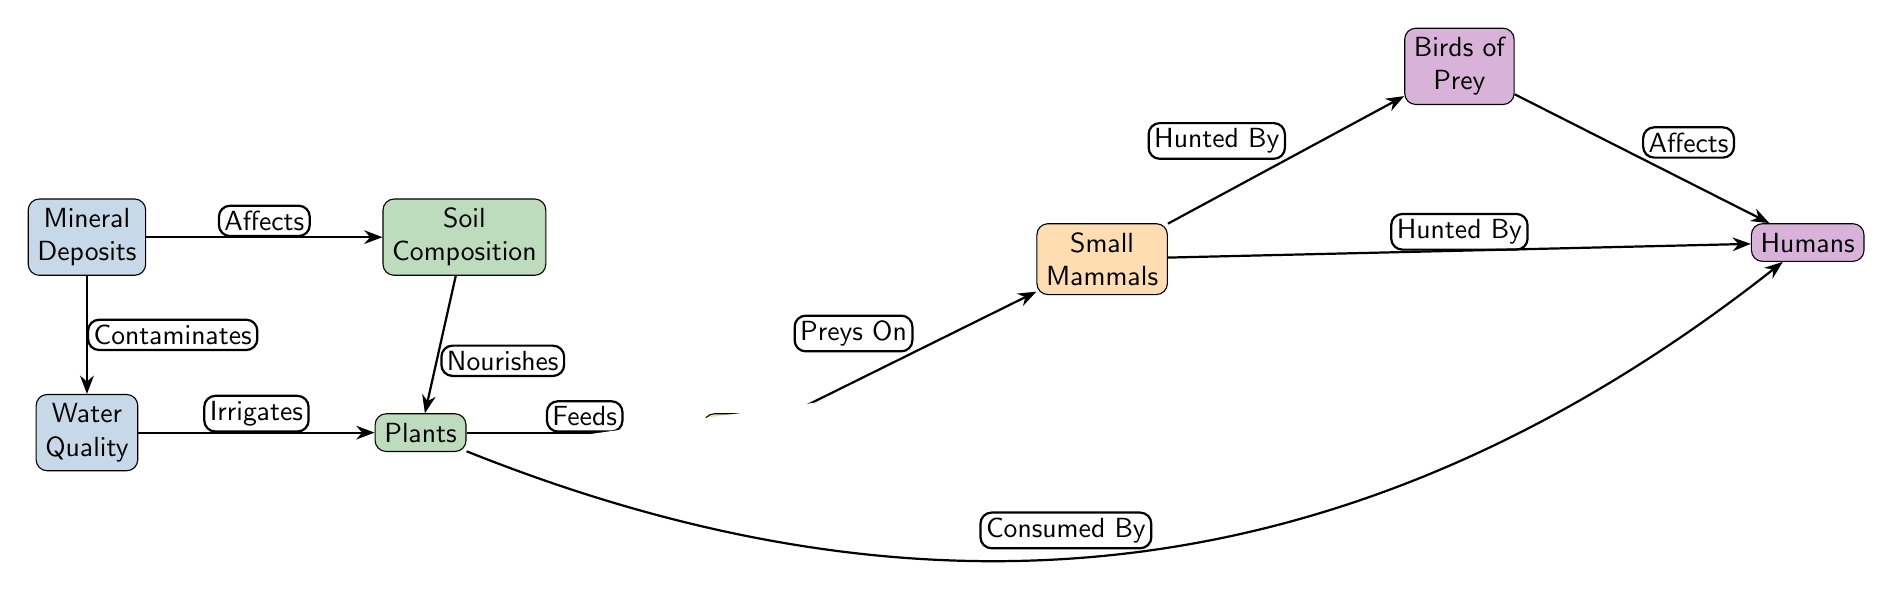What is the first node in the diagram? The first node in the diagram is labeled "Mineral Deposits," which is placed at the top.
Answer: Mineral Deposits How many nodes are there in total? By counting all the unique elements represented in the diagram including "Mineral Deposits," "Soil Composition," "Water Quality," "Plants," "Insects," "Small Mammals," "Birds of Prey," and "Humans," we find eight nodes.
Answer: 8 What flows from "Mineral Deposits" to "Soil Composition"? The relationship is described by the word "Affects," indicating a direct influence from "Mineral Deposits" to "Soil Composition."
Answer: Affects Which node is directly below "Water Quality"? The node directly below "Water Quality" is "Plants," which is connected by the irrigation relationship.
Answer: Plants What relationship connects "Insects" to "Small Mammals"? The relationship is defined as "Preys On," indicating that small mammals feed on insects.
Answer: Preys On How does "Soil Composition" impact "Plants"? "Soil Composition" is labeled with the relationship "Nourishes," which shows its positive effect on plant growth and health.
Answer: Nourishes What are the two nodes that have a direct relationship with "Humans"? The nodes with a direct relationship to "Humans" are "Plants" (through "Consumed By") and "Small Mammals" (through "Hunted By"), indicating human interaction with both categories in different ways.
Answer: Plants and Small Mammals What is the last node in the diagram? The last node is "Humans," which represents the final consumer in this food chain, placed at the bottom right of the diagram.
Answer: Humans What is the relationship between "Birds of Prey" and "Humans"? The relationship is labeled "Affects," which suggests that birds of prey play a role that can influence humans, possibly in ecological or environmental contexts.
Answer: Affects 